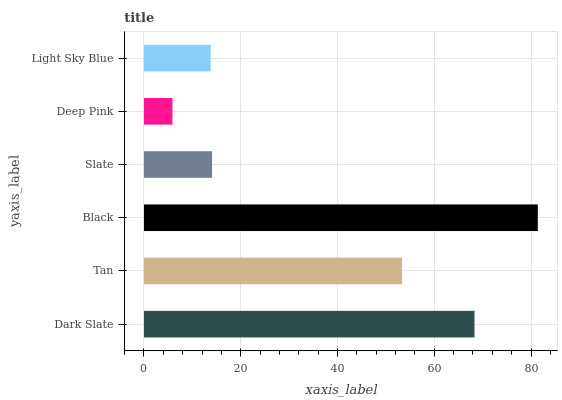Is Deep Pink the minimum?
Answer yes or no. Yes. Is Black the maximum?
Answer yes or no. Yes. Is Tan the minimum?
Answer yes or no. No. Is Tan the maximum?
Answer yes or no. No. Is Dark Slate greater than Tan?
Answer yes or no. Yes. Is Tan less than Dark Slate?
Answer yes or no. Yes. Is Tan greater than Dark Slate?
Answer yes or no. No. Is Dark Slate less than Tan?
Answer yes or no. No. Is Tan the high median?
Answer yes or no. Yes. Is Slate the low median?
Answer yes or no. Yes. Is Deep Pink the high median?
Answer yes or no. No. Is Dark Slate the low median?
Answer yes or no. No. 